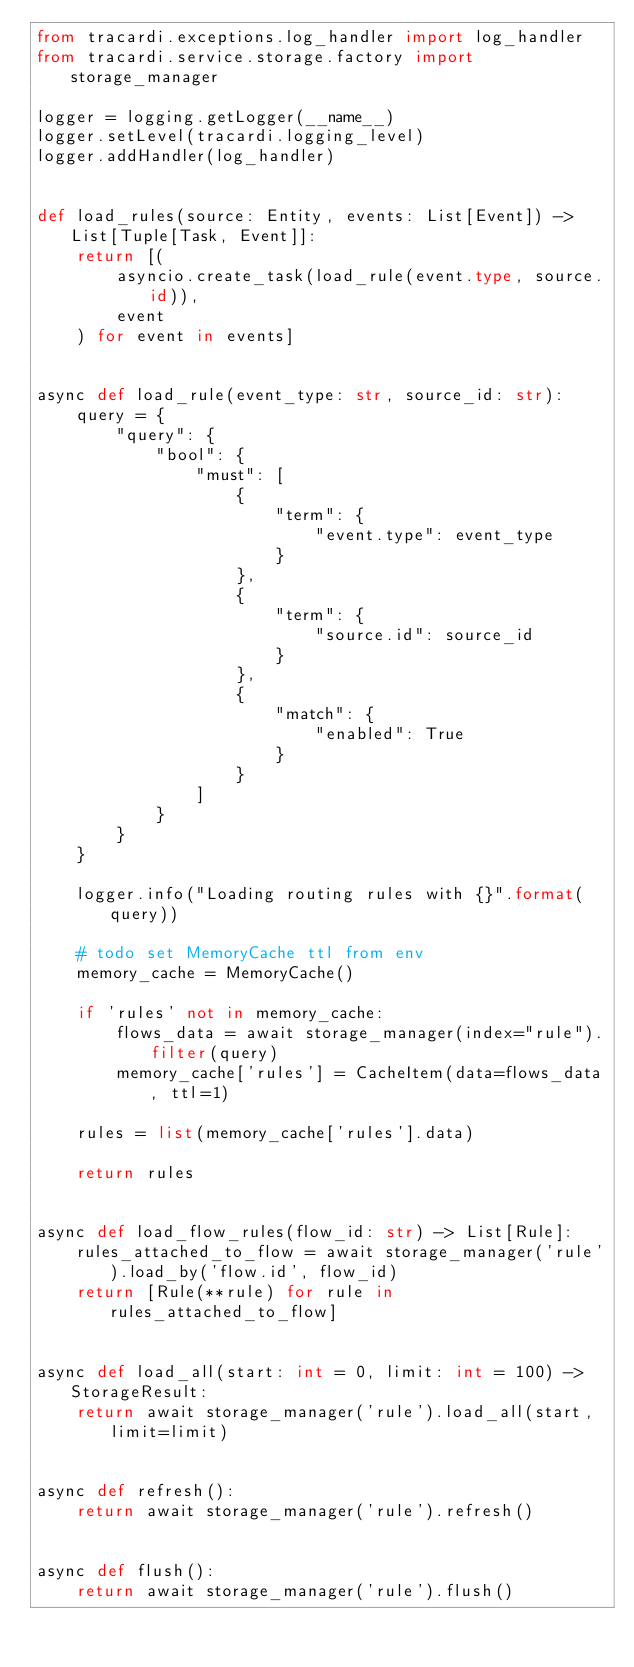<code> <loc_0><loc_0><loc_500><loc_500><_Python_>from tracardi.exceptions.log_handler import log_handler
from tracardi.service.storage.factory import storage_manager

logger = logging.getLogger(__name__)
logger.setLevel(tracardi.logging_level)
logger.addHandler(log_handler)


def load_rules(source: Entity, events: List[Event]) -> List[Tuple[Task, Event]]:
    return [(
        asyncio.create_task(load_rule(event.type, source.id)),
        event
    ) for event in events]


async def load_rule(event_type: str, source_id: str):
    query = {
        "query": {
            "bool": {
                "must": [
                    {
                        "term": {
                            "event.type": event_type
                        }
                    },
                    {
                        "term": {
                            "source.id": source_id
                        }
                    },
                    {
                        "match": {
                            "enabled": True
                        }
                    }
                ]
            }
        }
    }

    logger.info("Loading routing rules with {}".format(query))

    # todo set MemoryCache ttl from env
    memory_cache = MemoryCache()

    if 'rules' not in memory_cache:
        flows_data = await storage_manager(index="rule").filter(query)
        memory_cache['rules'] = CacheItem(data=flows_data, ttl=1)

    rules = list(memory_cache['rules'].data)

    return rules


async def load_flow_rules(flow_id: str) -> List[Rule]:
    rules_attached_to_flow = await storage_manager('rule').load_by('flow.id', flow_id)
    return [Rule(**rule) for rule in rules_attached_to_flow]


async def load_all(start: int = 0, limit: int = 100) -> StorageResult:
    return await storage_manager('rule').load_all(start, limit=limit)


async def refresh():
    return await storage_manager('rule').refresh()


async def flush():
    return await storage_manager('rule').flush()
</code> 